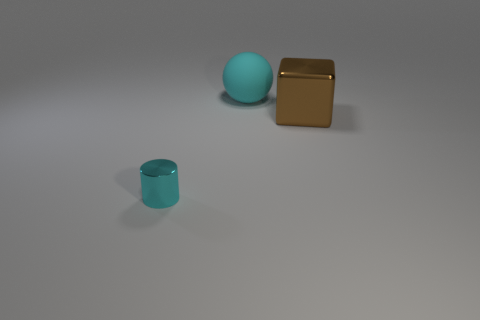Is there any other thing that is the same size as the cyan cylinder?
Make the answer very short. No. Do the brown metallic block and the shiny object left of the big cyan ball have the same size?
Ensure brevity in your answer.  No. What number of rubber objects are big cyan blocks or big blocks?
Provide a succinct answer. 0. What shape is the other object that is the same color as the big rubber object?
Provide a succinct answer. Cylinder. What is the cyan thing right of the tiny cyan thing made of?
Ensure brevity in your answer.  Rubber. What number of things are gray matte objects or cyan objects that are behind the shiny cylinder?
Keep it short and to the point. 1. The rubber object that is the same size as the brown shiny cube is what shape?
Make the answer very short. Sphere. How many things are the same color as the sphere?
Offer a terse response. 1. Do the cyan thing that is behind the block and the tiny cyan thing have the same material?
Make the answer very short. No. There is a brown object; what shape is it?
Your answer should be very brief. Cube. 